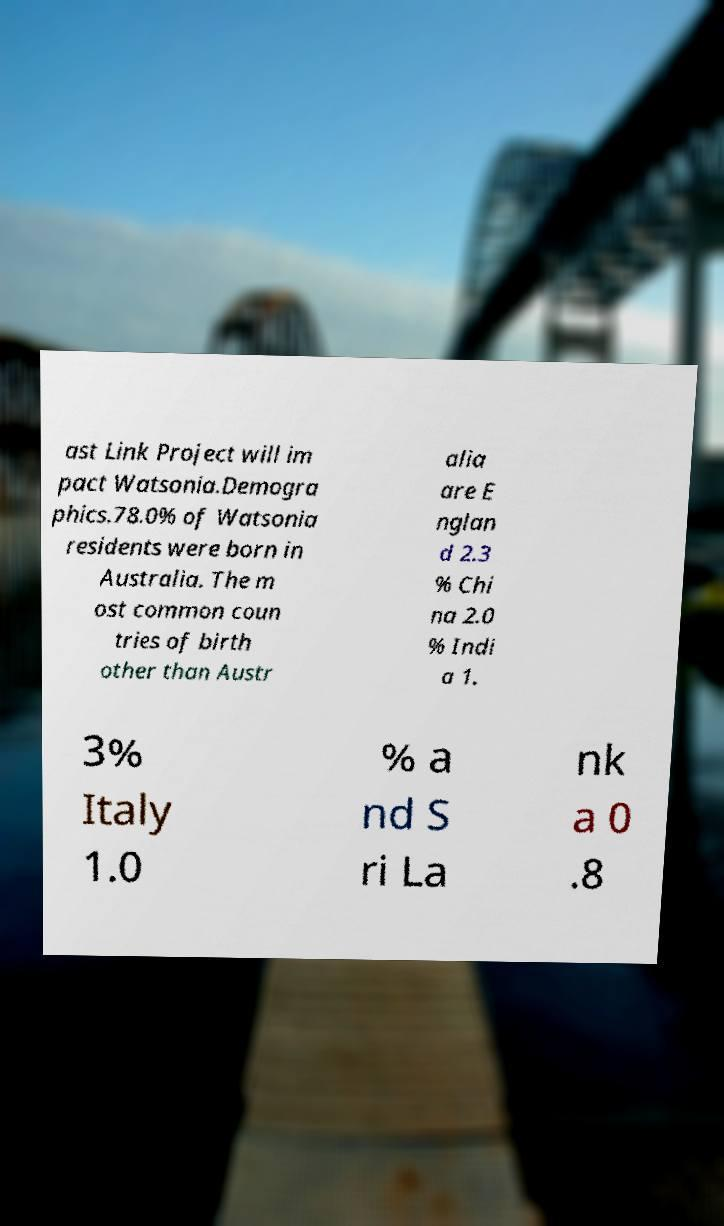For documentation purposes, I need the text within this image transcribed. Could you provide that? ast Link Project will im pact Watsonia.Demogra phics.78.0% of Watsonia residents were born in Australia. The m ost common coun tries of birth other than Austr alia are E nglan d 2.3 % Chi na 2.0 % Indi a 1. 3% Italy 1.0 % a nd S ri La nk a 0 .8 